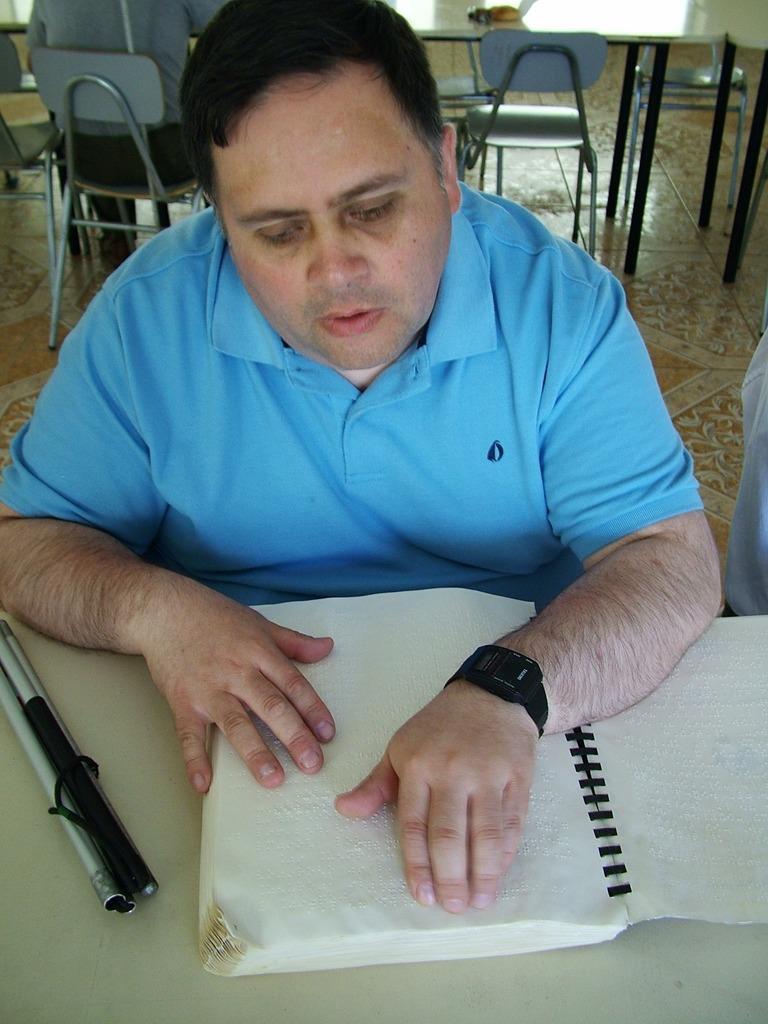Describe this image in one or two sentences. This image describes about a book and stick on the table, and we can see three people are seated on the chair. 